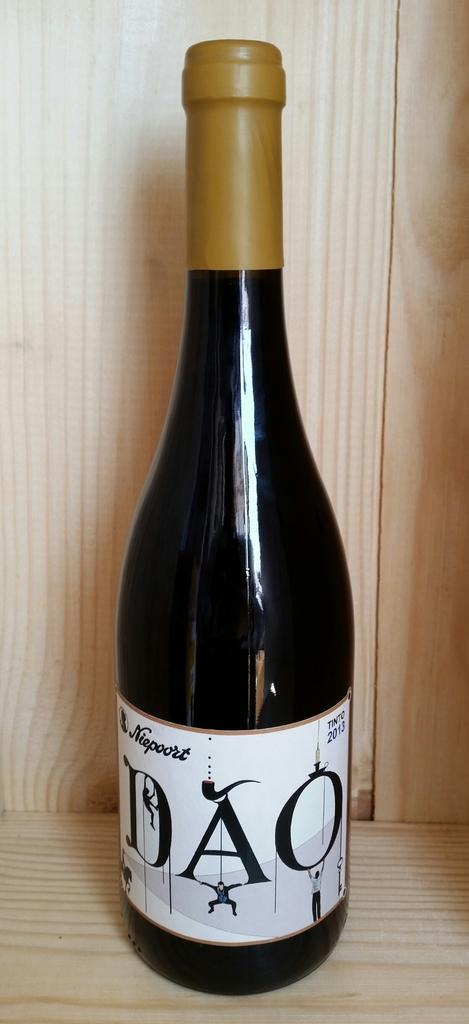<image>
Offer a succinct explanation of the picture presented. A bottle of DAO from Niepoort sits in a wooden crate. 